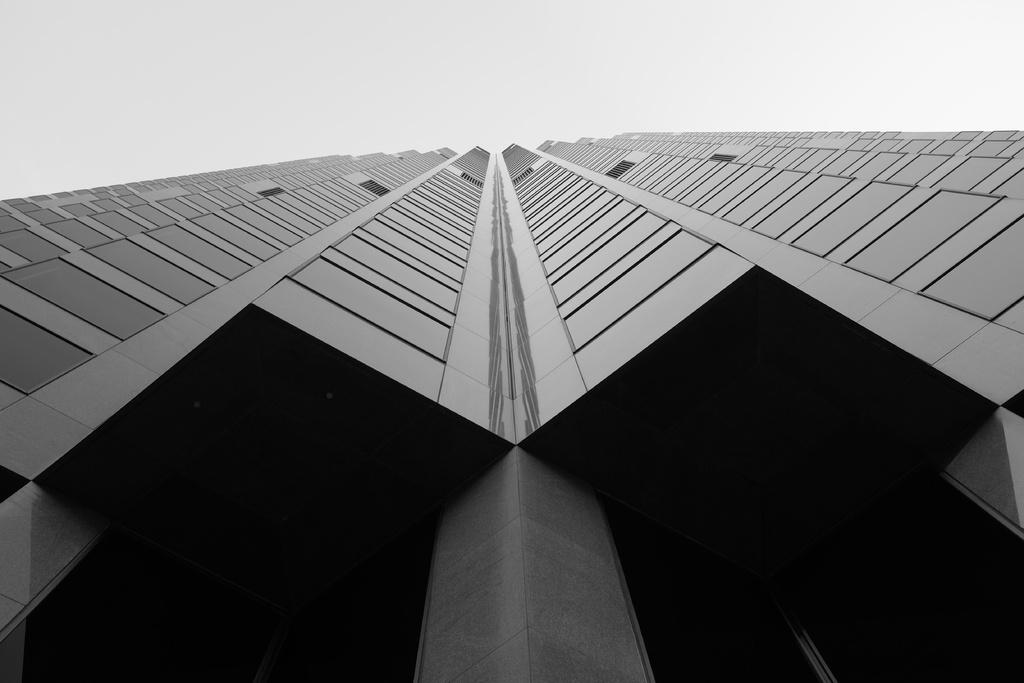What is the color scheme of the picture? The picture is black and white. What can be seen in the picture? There is a building in the picture. What type of appliance can be seen in the yard in the picture? There is no appliance or yard present in the picture; it only features a black and white building. 